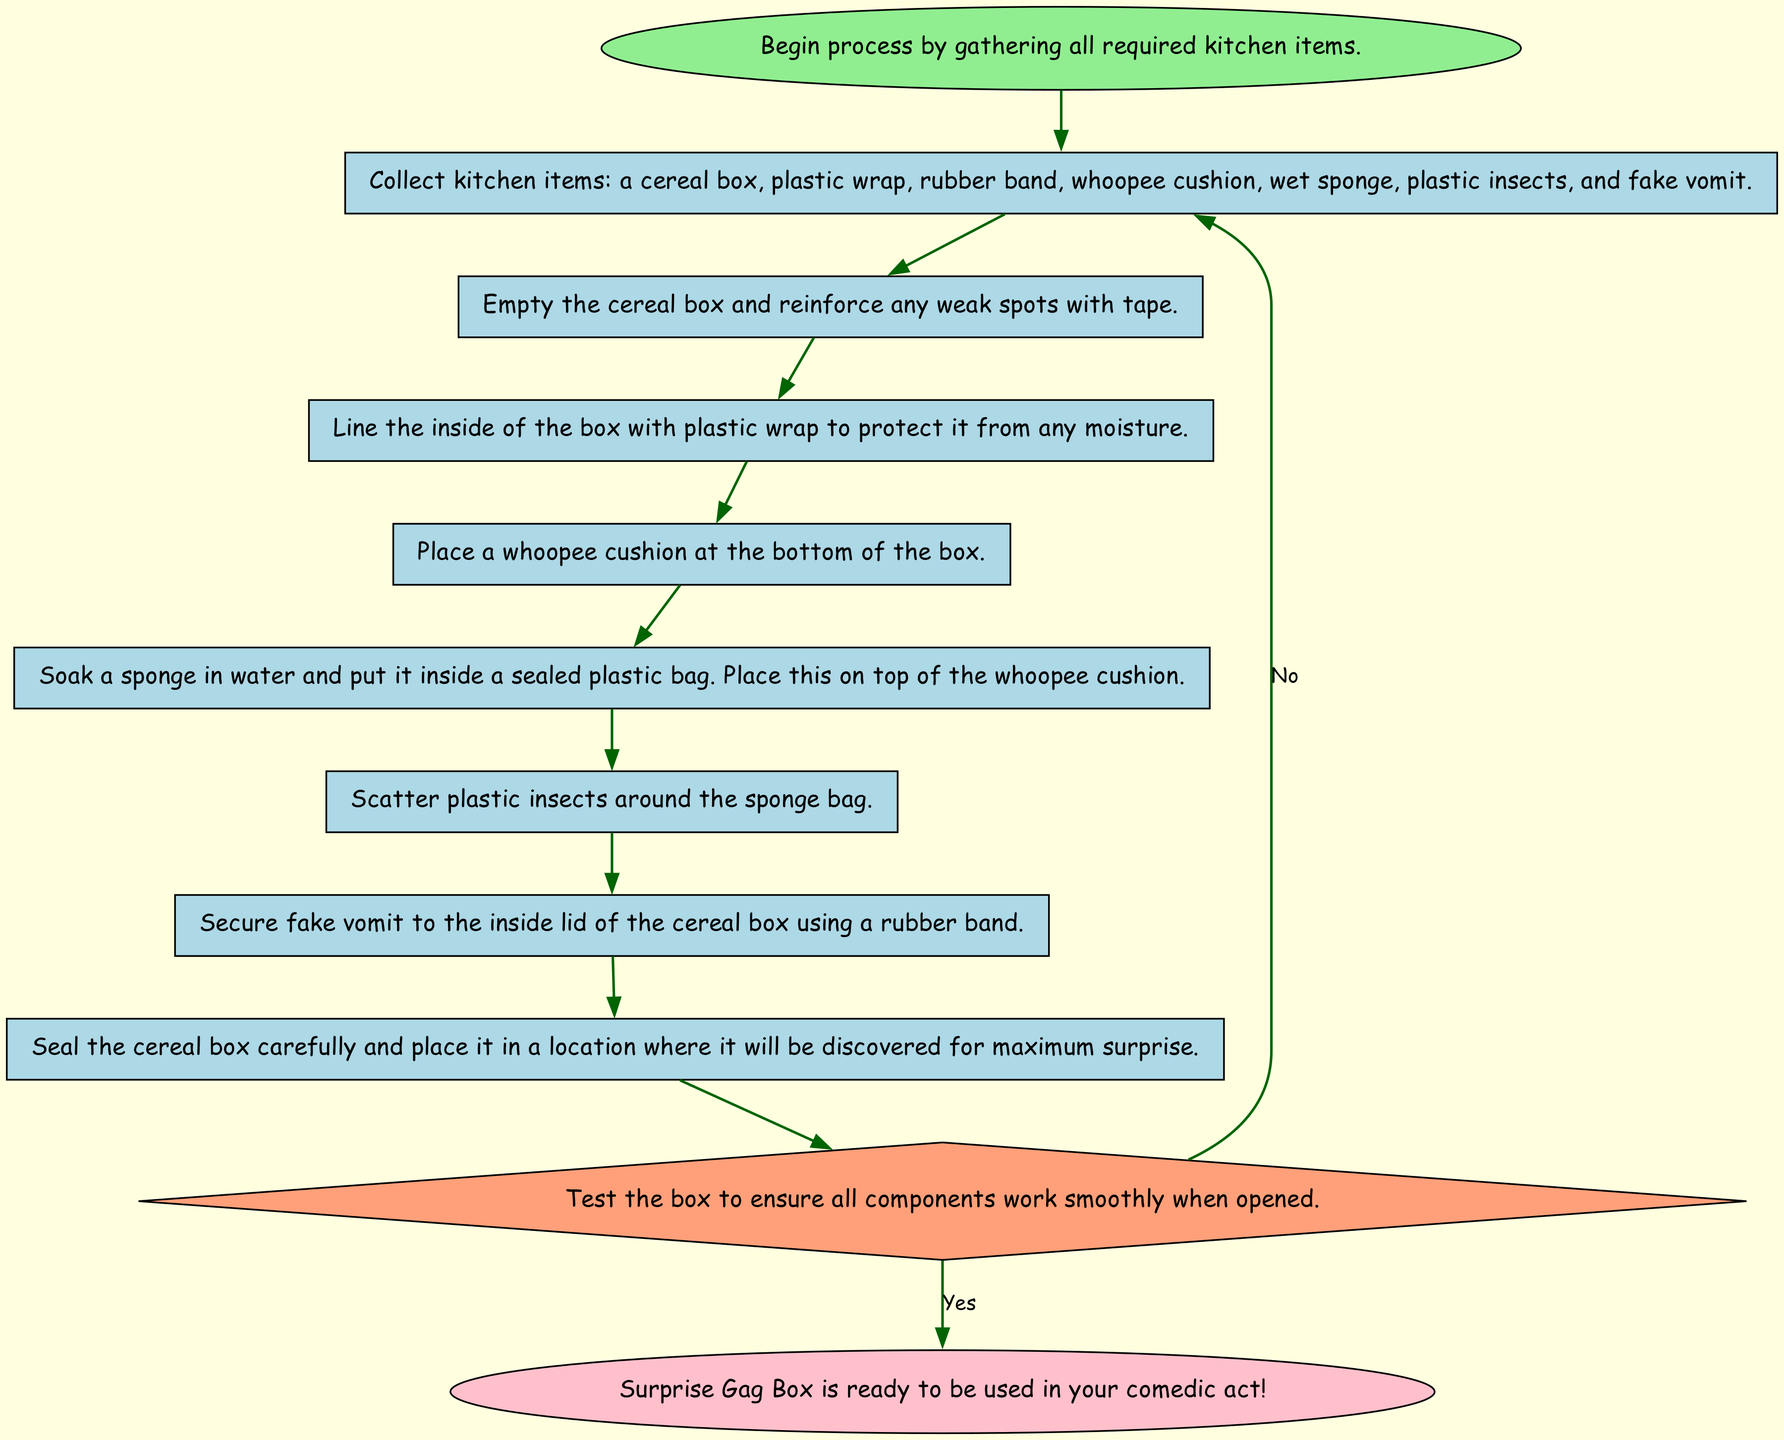What is the first step in creating the Surprise Gag Box? The first step is to gather all required kitchen items. This is shown as the starting node labeled "Begin process by gathering all required kitchen items."
Answer: Begin process by gathering all required kitchen items How many kitchen items need to be collected? The flowchart lists seven specific items that need to be collected: a cereal box, plastic wrap, rubber band, whoopee cushion, wet sponge, plastic insects, and fake vomit. Adding these gives a total of seven items.
Answer: Seven What should be done after collecting the items? After gathering the kitchen items, the next step is to prepare the cereal box which involves emptying it and reinforcing any weak spots with tape. This follows immediately after the gathering step.
Answer: Prepare cereal box What action comes after inserting the whoopee cushion? The flowchart indicates that after placing the whoopee cushion at the bottom of the box, the next step is to soak a sponge in water and seal it in a plastic bag. This shows the order of actions in the process.
Answer: Add sponge What happens if the test reveals that the components do not work smoothly? According to the diagram, if the test determines the components do not work smoothly when opened, the next step will direct you back to gathering the kitchen items. This represents a feedback loop in the process.
Answer: Gather items How does the creation process conclude? The flowchart concludes with the node labeled "Surprise Gag Box is ready to be used in your comedic act!" which signifies the end of the process successfully. This is reached after passing the test stage affirmatively.
Answer: Surprise Gag Box is ready to be used in your comedic act! 